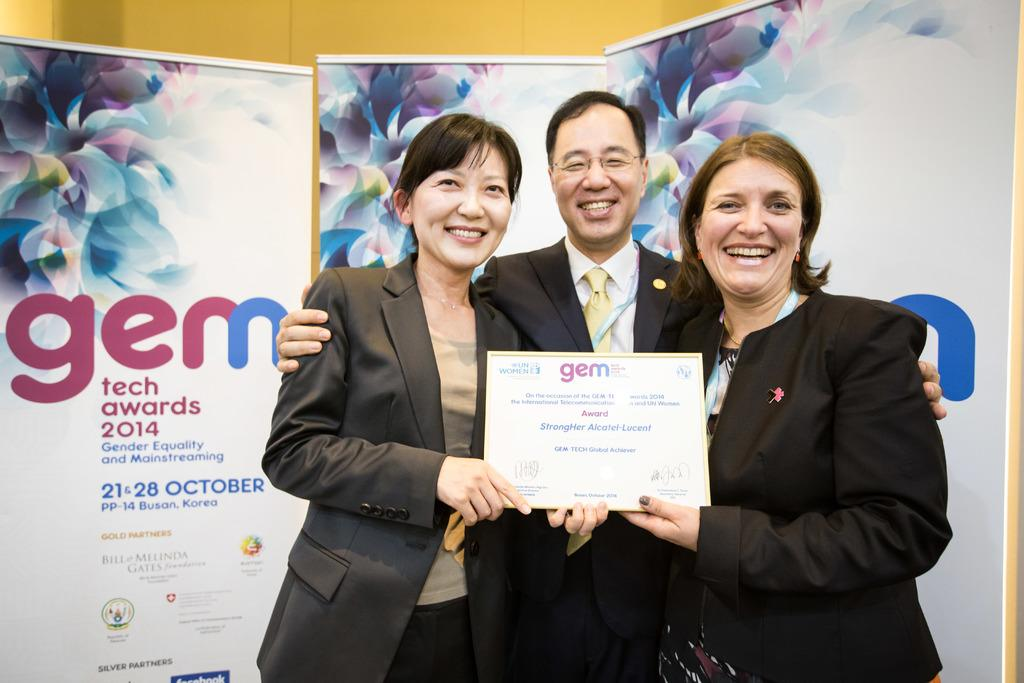How many people are in the image? There are three persons in the image. What are the three persons doing in the image? The three persons are standing in the image. What is located behind the three persons? The three persons are in front of banners. What are the three persons wearing? The three persons are wearing clothes. What are two of the persons holding in the image? Two of the persons are holding an award with their hands. What type of engine can be seen in the image? There is no engine present in the image. What act are the three persons performing in the image? The image does not depict a specific act or performance; it simply shows three persons standing in front of banners. 